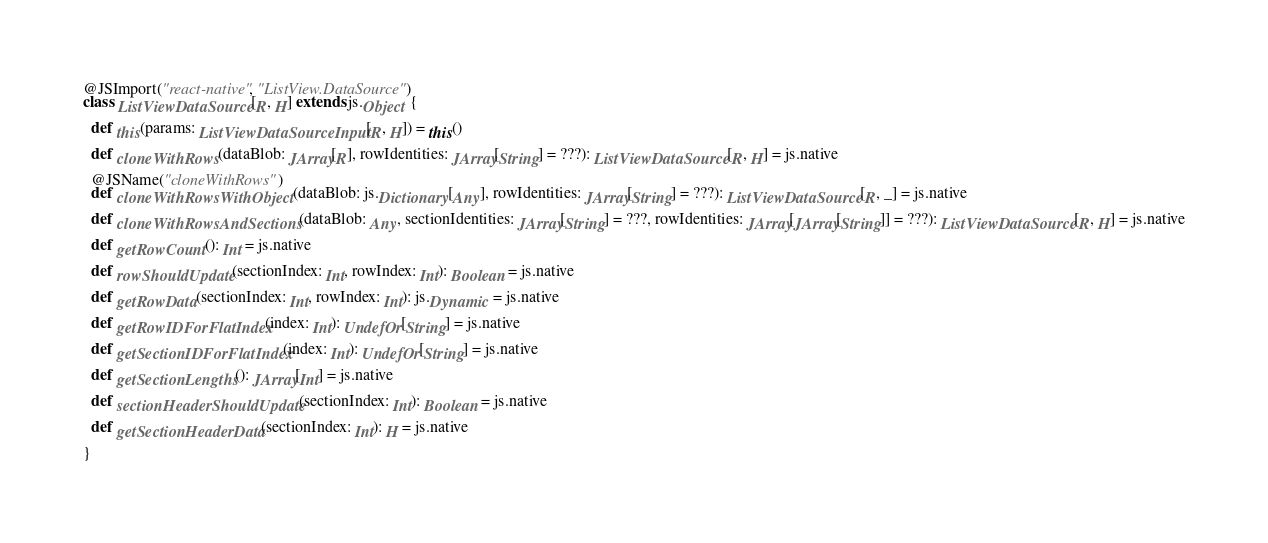Convert code to text. <code><loc_0><loc_0><loc_500><loc_500><_Scala_>@JSImport("react-native", "ListView.DataSource")
class ListViewDataSource[R, H] extends js.Object {

  def this(params: ListViewDataSourceInput[R, H]) = this()

  def cloneWithRows(dataBlob: JArray[R], rowIdentities: JArray[String] = ???): ListViewDataSource[R, H] = js.native

  @JSName("cloneWithRows")
  def cloneWithRowsWithObject(dataBlob: js.Dictionary[Any], rowIdentities: JArray[String] = ???): ListViewDataSource[R, _] = js.native

  def cloneWithRowsAndSections(dataBlob: Any, sectionIdentities: JArray[String] = ???, rowIdentities: JArray[JArray[String]] = ???): ListViewDataSource[R, H] = js.native

  def getRowCount(): Int = js.native

  def rowShouldUpdate(sectionIndex: Int, rowIndex: Int): Boolean = js.native

  def getRowData(sectionIndex: Int, rowIndex: Int): js.Dynamic = js.native

  def getRowIDForFlatIndex(index: Int): UndefOr[String] = js.native

  def getSectionIDForFlatIndex(index: Int): UndefOr[String] = js.native

  def getSectionLengths(): JArray[Int] = js.native

  def sectionHeaderShouldUpdate(sectionIndex: Int): Boolean = js.native

  def getSectionHeaderData(sectionIndex: Int): H = js.native

}
</code> 